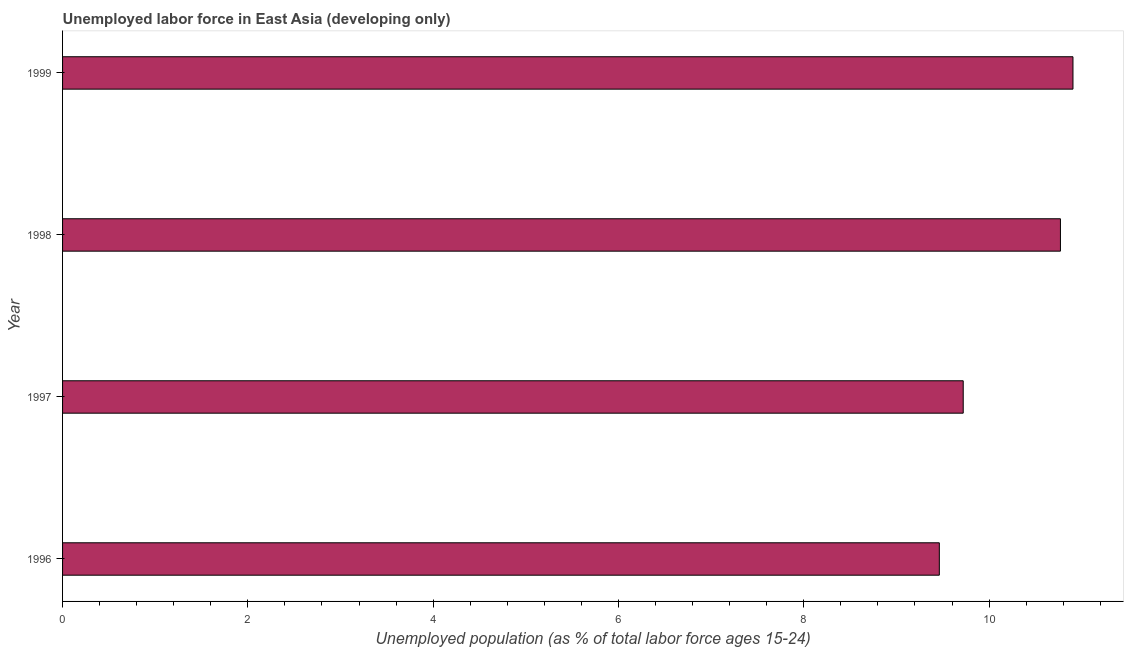Does the graph contain grids?
Your response must be concise. No. What is the title of the graph?
Your response must be concise. Unemployed labor force in East Asia (developing only). What is the label or title of the X-axis?
Make the answer very short. Unemployed population (as % of total labor force ages 15-24). What is the total unemployed youth population in 1998?
Offer a very short reply. 10.77. Across all years, what is the maximum total unemployed youth population?
Offer a terse response. 10.91. Across all years, what is the minimum total unemployed youth population?
Provide a succinct answer. 9.46. In which year was the total unemployed youth population maximum?
Make the answer very short. 1999. In which year was the total unemployed youth population minimum?
Make the answer very short. 1996. What is the sum of the total unemployed youth population?
Provide a short and direct response. 40.86. What is the difference between the total unemployed youth population in 1997 and 1999?
Your answer should be compact. -1.19. What is the average total unemployed youth population per year?
Offer a very short reply. 10.21. What is the median total unemployed youth population?
Offer a very short reply. 10.25. Do a majority of the years between 1998 and 1996 (inclusive) have total unemployed youth population greater than 10 %?
Offer a terse response. Yes. What is the ratio of the total unemployed youth population in 1998 to that in 1999?
Your answer should be very brief. 0.99. Is the total unemployed youth population in 1997 less than that in 1998?
Make the answer very short. Yes. Is the difference between the total unemployed youth population in 1997 and 1999 greater than the difference between any two years?
Your answer should be compact. No. What is the difference between the highest and the second highest total unemployed youth population?
Provide a short and direct response. 0.14. Is the sum of the total unemployed youth population in 1997 and 1998 greater than the maximum total unemployed youth population across all years?
Offer a terse response. Yes. What is the difference between the highest and the lowest total unemployed youth population?
Offer a terse response. 1.44. How many bars are there?
Offer a very short reply. 4. What is the difference between two consecutive major ticks on the X-axis?
Offer a very short reply. 2. What is the Unemployed population (as % of total labor force ages 15-24) of 1996?
Your answer should be very brief. 9.46. What is the Unemployed population (as % of total labor force ages 15-24) of 1997?
Give a very brief answer. 9.72. What is the Unemployed population (as % of total labor force ages 15-24) in 1998?
Ensure brevity in your answer.  10.77. What is the Unemployed population (as % of total labor force ages 15-24) in 1999?
Provide a short and direct response. 10.91. What is the difference between the Unemployed population (as % of total labor force ages 15-24) in 1996 and 1997?
Offer a very short reply. -0.26. What is the difference between the Unemployed population (as % of total labor force ages 15-24) in 1996 and 1998?
Provide a short and direct response. -1.31. What is the difference between the Unemployed population (as % of total labor force ages 15-24) in 1996 and 1999?
Your answer should be compact. -1.44. What is the difference between the Unemployed population (as % of total labor force ages 15-24) in 1997 and 1998?
Keep it short and to the point. -1.05. What is the difference between the Unemployed population (as % of total labor force ages 15-24) in 1997 and 1999?
Your answer should be compact. -1.18. What is the difference between the Unemployed population (as % of total labor force ages 15-24) in 1998 and 1999?
Provide a short and direct response. -0.14. What is the ratio of the Unemployed population (as % of total labor force ages 15-24) in 1996 to that in 1998?
Offer a very short reply. 0.88. What is the ratio of the Unemployed population (as % of total labor force ages 15-24) in 1996 to that in 1999?
Keep it short and to the point. 0.87. What is the ratio of the Unemployed population (as % of total labor force ages 15-24) in 1997 to that in 1998?
Make the answer very short. 0.9. What is the ratio of the Unemployed population (as % of total labor force ages 15-24) in 1997 to that in 1999?
Provide a short and direct response. 0.89. 